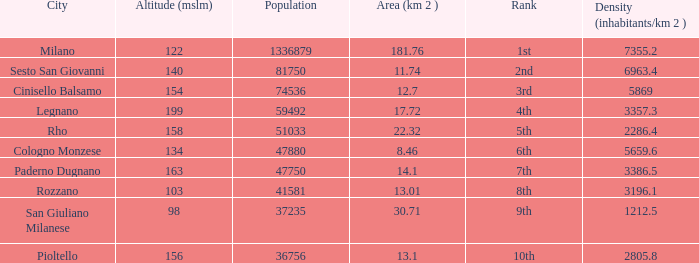Which Population has an Altitude (mslm) larger than 98, and a Density (inhabitants/km 2) larger than 5869, and a Rank of 1st? 1336879.0. 